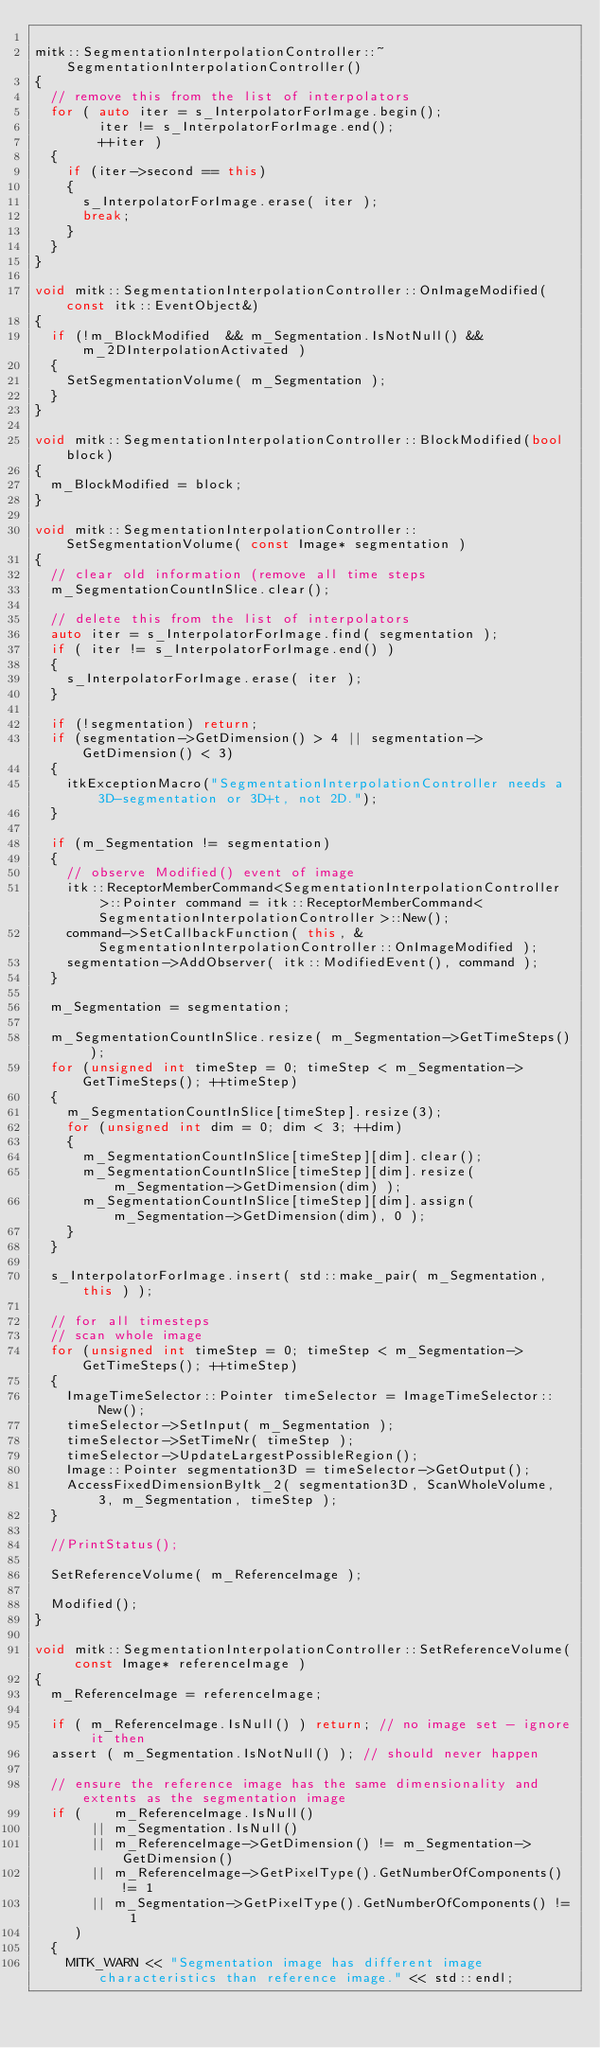Convert code to text. <code><loc_0><loc_0><loc_500><loc_500><_C++_>
mitk::SegmentationInterpolationController::~SegmentationInterpolationController()
{
  // remove this from the list of interpolators
  for ( auto iter = s_InterpolatorForImage.begin();
        iter != s_InterpolatorForImage.end();
        ++iter )
  {
    if (iter->second == this)
    {
      s_InterpolatorForImage.erase( iter );
      break;
    }
  }
}

void mitk::SegmentationInterpolationController::OnImageModified(const itk::EventObject&)
{
  if (!m_BlockModified  && m_Segmentation.IsNotNull() && m_2DInterpolationActivated )
  {
    SetSegmentationVolume( m_Segmentation );
  }
}

void mitk::SegmentationInterpolationController::BlockModified(bool block)
{
  m_BlockModified = block;
}

void mitk::SegmentationInterpolationController::SetSegmentationVolume( const Image* segmentation )
{
  // clear old information (remove all time steps
  m_SegmentationCountInSlice.clear();

  // delete this from the list of interpolators
  auto iter = s_InterpolatorForImage.find( segmentation );
  if ( iter != s_InterpolatorForImage.end() )
  {
    s_InterpolatorForImage.erase( iter );
  }

  if (!segmentation) return;
  if (segmentation->GetDimension() > 4 || segmentation->GetDimension() < 3)
  {
    itkExceptionMacro("SegmentationInterpolationController needs a 3D-segmentation or 3D+t, not 2D.");
  }

  if (m_Segmentation != segmentation)
  {
    // observe Modified() event of image
    itk::ReceptorMemberCommand<SegmentationInterpolationController>::Pointer command = itk::ReceptorMemberCommand<SegmentationInterpolationController>::New();
    command->SetCallbackFunction( this, &SegmentationInterpolationController::OnImageModified );
    segmentation->AddObserver( itk::ModifiedEvent(), command );
  }

  m_Segmentation = segmentation;

  m_SegmentationCountInSlice.resize( m_Segmentation->GetTimeSteps() );
  for (unsigned int timeStep = 0; timeStep < m_Segmentation->GetTimeSteps(); ++timeStep)
  {
    m_SegmentationCountInSlice[timeStep].resize(3);
    for (unsigned int dim = 0; dim < 3; ++dim)
    {
      m_SegmentationCountInSlice[timeStep][dim].clear();
      m_SegmentationCountInSlice[timeStep][dim].resize( m_Segmentation->GetDimension(dim) );
      m_SegmentationCountInSlice[timeStep][dim].assign( m_Segmentation->GetDimension(dim), 0 );
    }
  }

  s_InterpolatorForImage.insert( std::make_pair( m_Segmentation, this ) );

  // for all timesteps
  // scan whole image
  for (unsigned int timeStep = 0; timeStep < m_Segmentation->GetTimeSteps(); ++timeStep)
  {
    ImageTimeSelector::Pointer timeSelector = ImageTimeSelector::New();
    timeSelector->SetInput( m_Segmentation );
    timeSelector->SetTimeNr( timeStep );
    timeSelector->UpdateLargestPossibleRegion();
    Image::Pointer segmentation3D = timeSelector->GetOutput();
    AccessFixedDimensionByItk_2( segmentation3D, ScanWholeVolume, 3, m_Segmentation, timeStep );
  }

  //PrintStatus();

  SetReferenceVolume( m_ReferenceImage );

  Modified();
}

void mitk::SegmentationInterpolationController::SetReferenceVolume( const Image* referenceImage )
{
  m_ReferenceImage = referenceImage;

  if ( m_ReferenceImage.IsNull() ) return; // no image set - ignore it then
  assert ( m_Segmentation.IsNotNull() ); // should never happen

  // ensure the reference image has the same dimensionality and extents as the segmentation image
  if (    m_ReferenceImage.IsNull()
       || m_Segmentation.IsNull()
       || m_ReferenceImage->GetDimension() != m_Segmentation->GetDimension()
       || m_ReferenceImage->GetPixelType().GetNumberOfComponents() != 1
       || m_Segmentation->GetPixelType().GetNumberOfComponents() != 1
     )
  {
    MITK_WARN << "Segmentation image has different image characteristics than reference image." << std::endl;</code> 